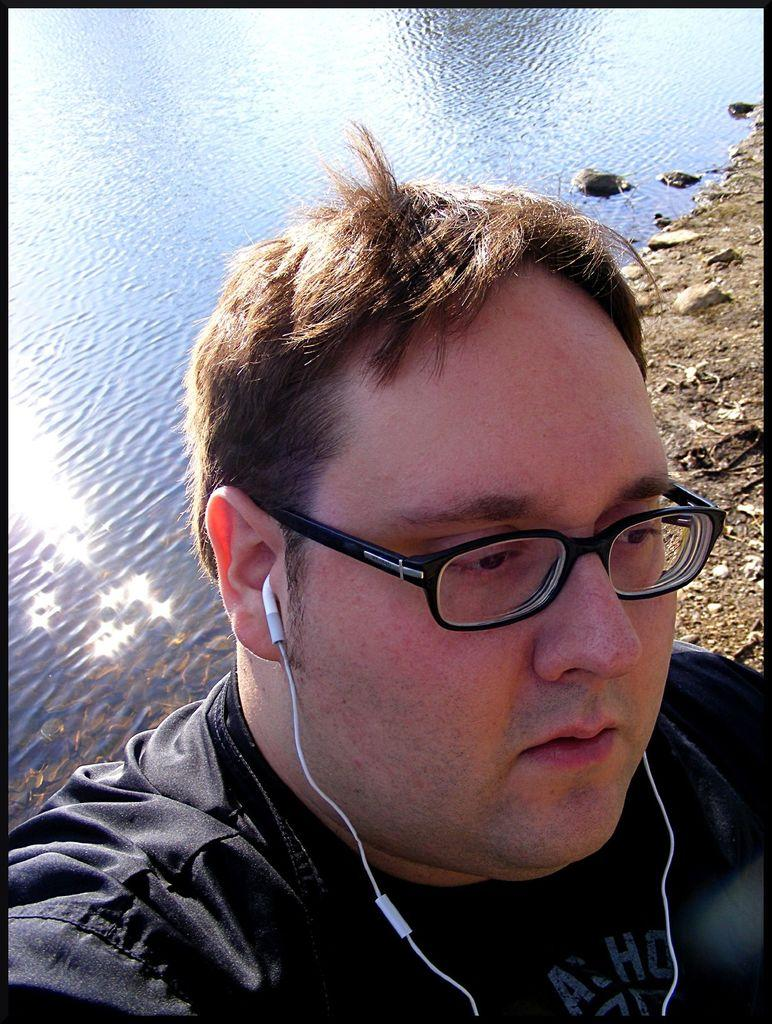Who is present in the image? There is a man in the image. What can be seen on the man's face? The man is wearing spectacles. What is the man wearing on his ears? The man is wearing earphones. What is visible in the background of the image? There is water visible behind the man. What type of terrain is on the right side of the image? There are rocks on the ground on the right side of the image. What route is the man taking during his recess in the image? There is no indication of a recess or a route in the image; it simply shows a man wearing spectacles and earphones with water and rocks visible in the background. 